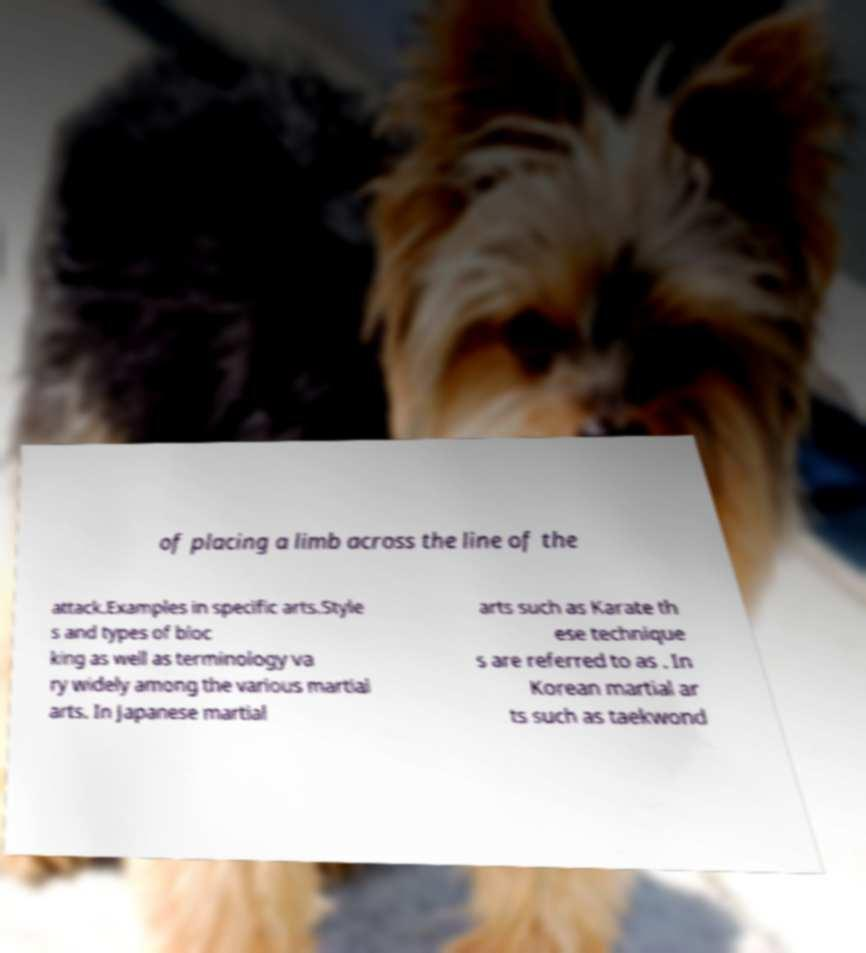Please read and relay the text visible in this image. What does it say? of placing a limb across the line of the attack.Examples in specific arts.Style s and types of bloc king as well as terminology va ry widely among the various martial arts. In Japanese martial arts such as Karate th ese technique s are referred to as . In Korean martial ar ts such as taekwond 